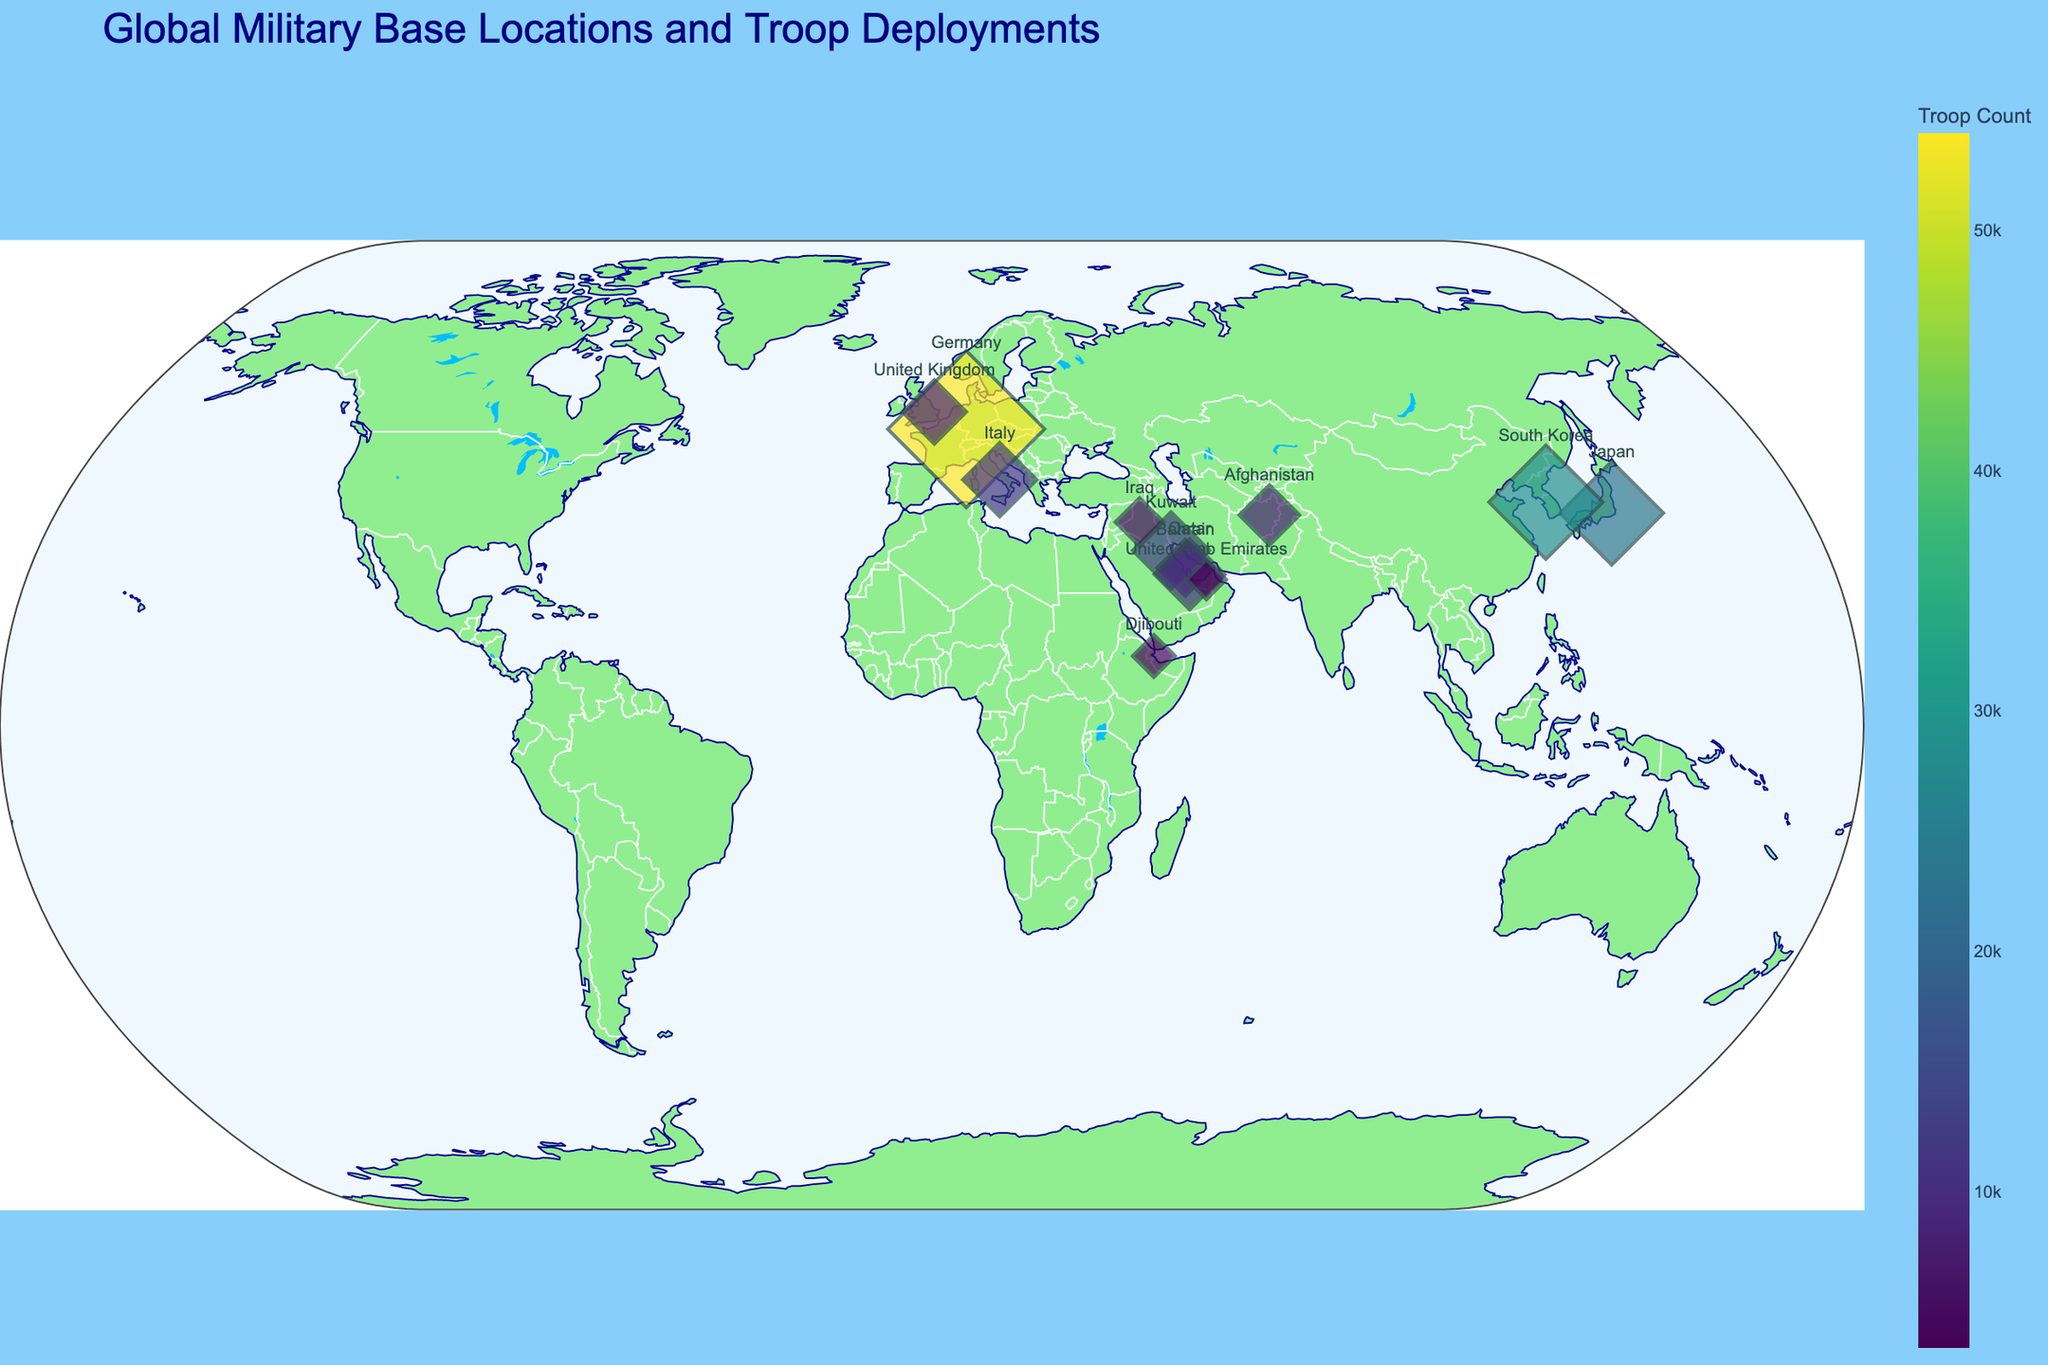What is the title of the figure? The title of any figure usually appears at the top of the plot and summarizes what the plot is about.
Answer: Global Military Base Locations and Troop Deployments Which country has the base with the highest number of troops? Identify the largest marker on the map as the size represents troop numbers. Then, check the hover name for that marker which shows the country and base name.
Answer: Germany How many countries are displayed on the map? Count the different countries labeled next to the markers on the map.
Answer: 12 Which country has the least number of troops deployed, and how many? Locate the smallest marker on the map and check its country and troop count.
Answer: United Arab Emirates, 3500 Compare the number of troops in Japan and South Korea. Which has more, and by how much? Find the markers for Japan and South Korea. Subtract the number of troops in Japan from those in South Korea.
Answer: South Korea has 500 more Which base is located furthest to the north? Identify the northernmost marker by checking the latitude values along the y-axis.
Answer: RAF Lakenheath (United Kingdom) What is the average number of troops across all the bases shown? Sum all the troop counts and divide by the number of bases. (54000 + 23500 + 28500 + 13000 + 12000 + 9000 + 7000 + 11000 + 8000 + 5200 + 3500 + 4000) / 12 = 182200 / 12
Answer: 15183 Which country has bases that are both nearest and farthest apart from each other in terms of troop deployment size? Identify the two bases within the same country and compare their troop size differences for each country; Kuwait (13000 - 12000 = 1000) has the smallest difference and Germany (54000 - 23500 = 30500) has the largest difference.
Answer: Germany and Kuwait What colors represent the troop counts in the figure? Check the color scale on the figure, which visually represents the troop numbers.
Answer: Viridis color scale, ranging from dark blue to light green How many bases are located in the Middle East? Identify and count bases in countries classified as part of the Middle East: Bahrain, Qatar, Kuwait, UAE.
Answer: 4 